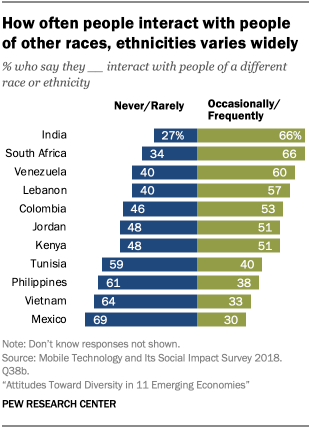Highlight a few significant elements in this photo. The first green bar from the top has a percentage value of 0.66... The median of the green bar is not smaller than the median of the blue bar. 